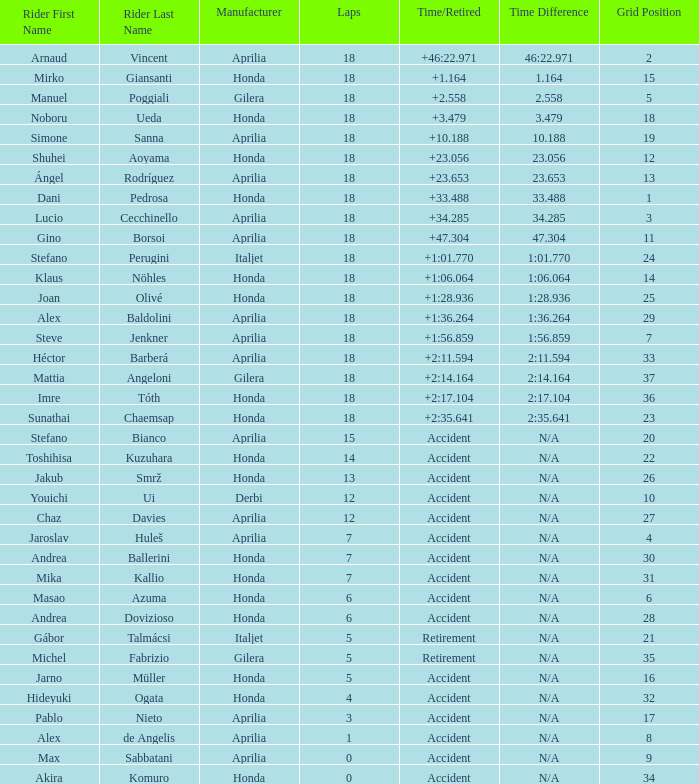What is the period/retirement for the honda maker with a grid smaller than 26, 18 laps, and joan olivé as the rider? +1:28.936. 